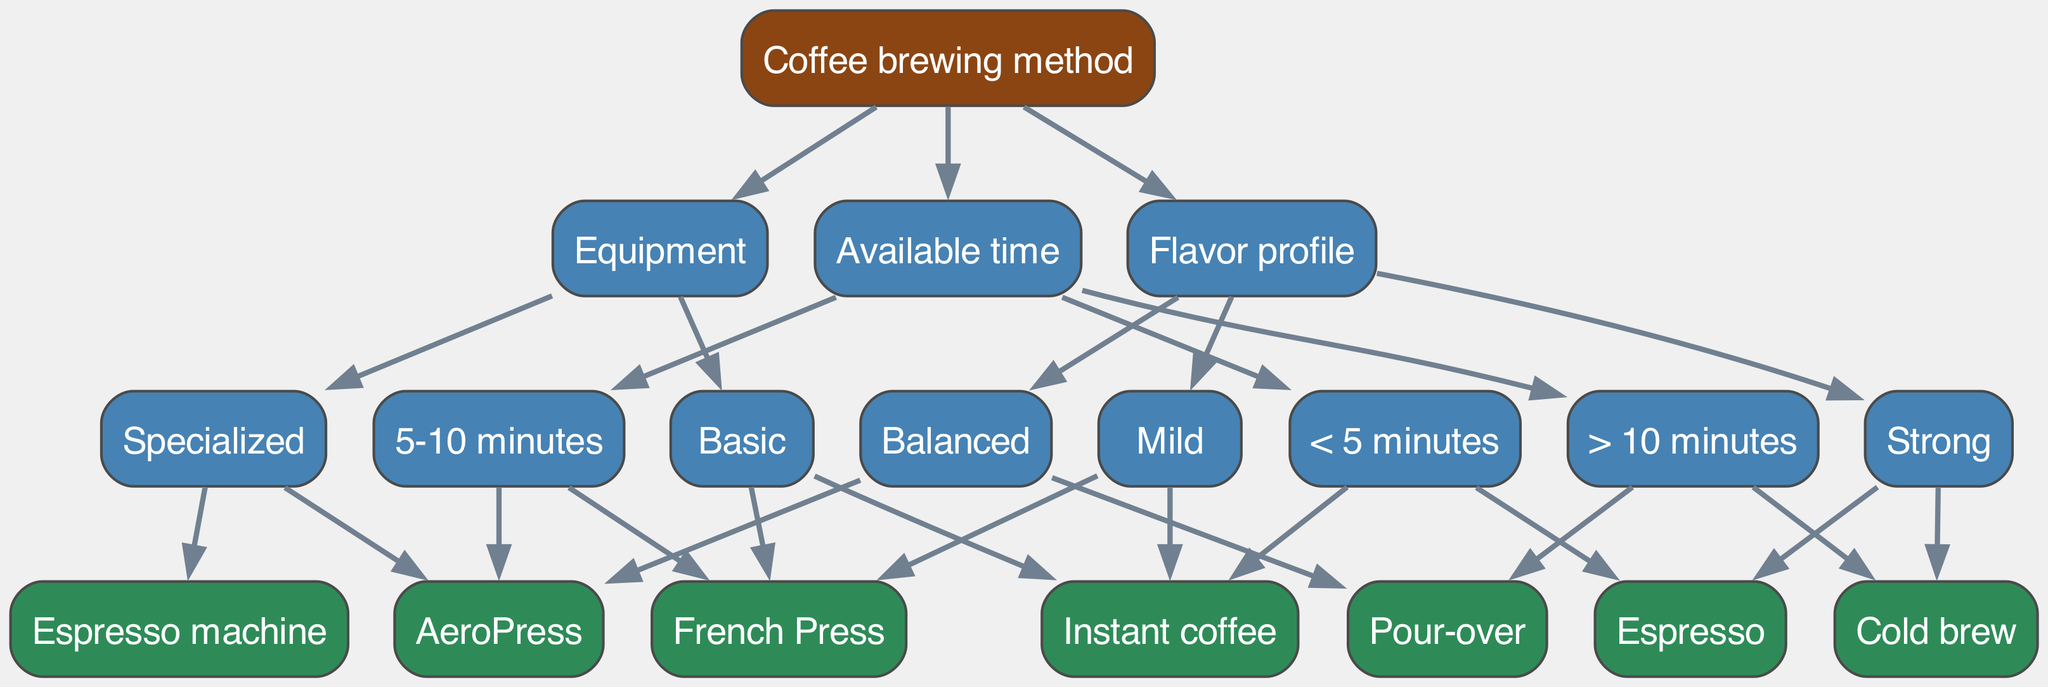What are the brewing methods if you have less than 5 minutes? The diagram branches out from the "Available time" node. Under the "< 5 minutes" category, both "Instant coffee" and "Espresso" are listed as brewing methods.
Answer: Instant coffee, Espresso How many children does the "Flavor profile" node have? The "Flavor profile" node branches out into three distinct categories: "Strong," "Balanced," and "Mild." Therefore, it has three children nodes.
Answer: 3 Which brewing method can be made with basic equipment? The "Equipment" node has branches for "Basic" and "Specialized." Under "Basic," both "Instant coffee" and "French Press" are listed as brewing methods.
Answer: Instant coffee, French Press If you want a balanced flavor profile, what brewing methods can you use? By following the "Flavor profile" node and selecting the "Balanced" category, you find "Pour-over" and "AeroPress" as the brewing methods that yield a balanced flavor profile.
Answer: Pour-over, AeroPress What is the preferred method for making strong coffee? The "Flavor profile" node's "Strong" category lists "Espresso" and "Cold brew." These are the methods recommended for strong coffee.
Answer: Espresso, Cold brew If you have specialized equipment, which brewing methods can you choose? The "Equipment" node specifies two categories. "Specialized" has two brewing methods: "Espresso machine" and "AeroPress," listed under it.
Answer: Espresso machine, AeroPress How does the decision tree categorize methods based on time? The diagram categorizes coffee brewing methods under "Available time," which has three branches: "< 5 minutes," "5-10 minutes," and "> 10 minutes." Each category lists corresponding methods.
Answer: Time categories: < 5 minutes, 5-10 minutes, > 10 minutes Which brewing method is suitable for someone with more than 10 minutes to brew? By examining the "> 10 minutes" branch under "Available time," the methods indicated are "Pour-over" and "Cold brew." These can be chosen when there is ample time for brewing.
Answer: Pour-over, Cold brew What node would you check to find a brewing method based on available equipment? To find brewing methods based on the available equipment, you would refer to the "Equipment" node as it categorizes the methods accordingly between "Basic" and "Specialized."
Answer: Equipment node 